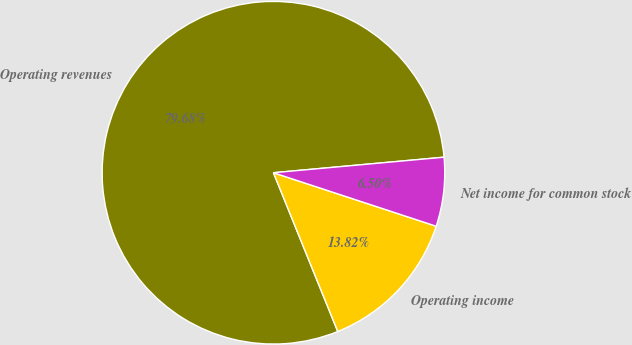Convert chart to OTSL. <chart><loc_0><loc_0><loc_500><loc_500><pie_chart><fcel>Operating revenues<fcel>Operating income<fcel>Net income for common stock<nl><fcel>79.68%<fcel>13.82%<fcel>6.5%<nl></chart> 